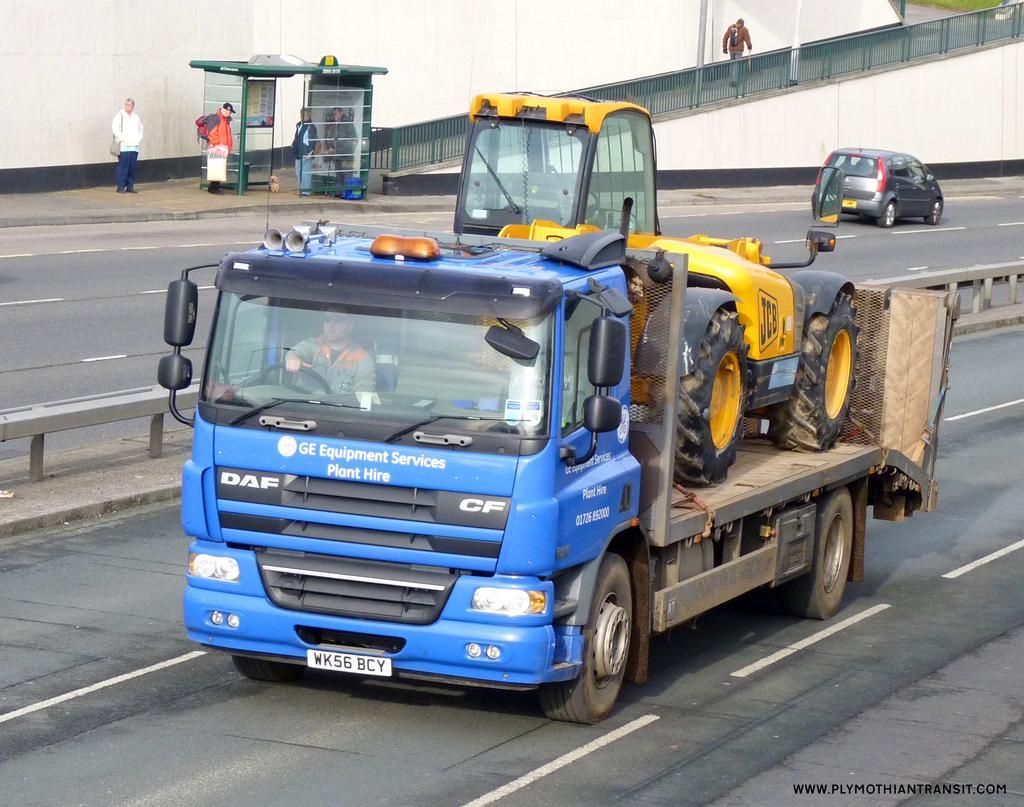Can you describe this image briefly? There are vehicles on the road. Here we can see few persons and a fence. In the background there is a wall. 